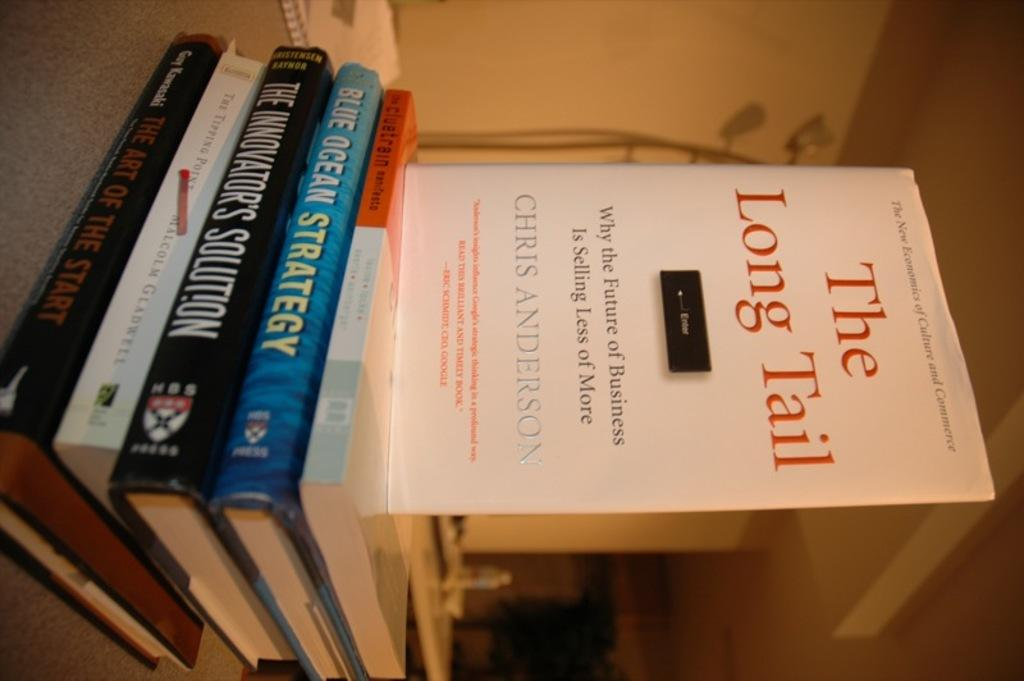Provide a one-sentence caption for the provided image. A book titled "The long tail" by Chris Anderson. 